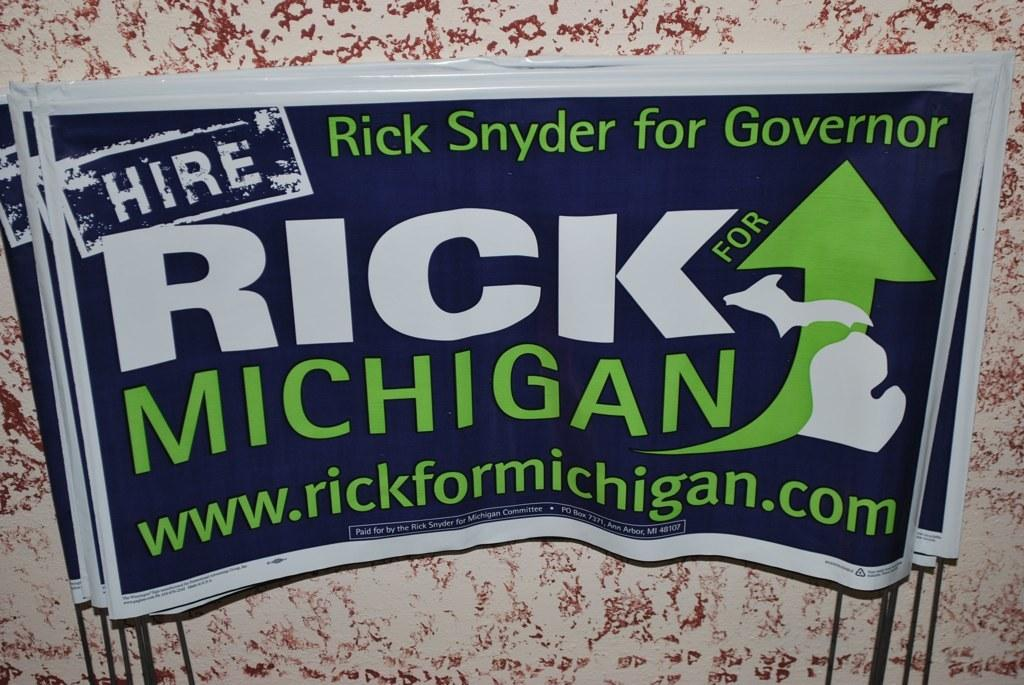<image>
Render a clear and concise summary of the photo. A stack of political signs that mention Rick Snyder. 